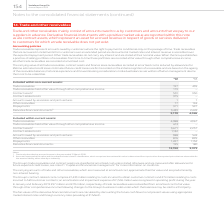According to Vodafone Group Plc's financial document, How much is the 2019 trade receivables included within non-current assets? According to the financial document, 197 (in millions). The relevant text states: "uded within non-current assets: Trade receivables 197 435 Trade receivables held at fair value through other comprehensive income 179 – Contract assets 1..." Also, How much is the 2018 trade receivables included within non-current assets? According to the financial document, 435 (in millions). The relevant text states: "within non-current assets: Trade receivables 197 435 Trade receivables held at fair value through other comprehensive income 179 – Contract assets 1 531..." Also, How much is the 2019 contract assets included within non-current assets? According to the financial document, 531 (in millions). The relevant text states: "ther comprehensive income 179 – Contract assets 1 531 350 Contract-related costs 375 – Amounts owed by associates and joint ventures 1 1 Other receivable..." Also, can you calculate: What is the average trade receivables included within non-current assets? To answer this question, I need to perform calculations using the financial data. The calculation is: (197+435)/2, which equals 316 (in millions). This is based on the information: "uded within non-current assets: Trade receivables 197 435 Trade receivables held at fair value through other comprehensive income 179 – Contract assets 1 within non-current assets: Trade receivables 1..." The key data points involved are: 197, 435. Also, can you calculate: What is the average prepayments included in non-current assets? To answer this question, I need to perform calculations using the financial data. The calculation is: (371+597)/2, which equals 484 (in millions). This is based on the information: "ventures 1 1 Other receivables 77 194 Prepayments 371 597 Derivative financial instruments 2 3,439 2,449 5,170 4,026 ures 1 1 Other receivables 77 194 Prepayments 371 597 Derivative financial instrume..." The key data points involved are: 371, 597. Additionally, Which year has higher trade receivables included within non-current assets? According to the financial document, 2018. The relevant text states: "2019 2018 €m €m Included within non-current assets: Trade receivables 197 435 Trade receivables held at fair..." 